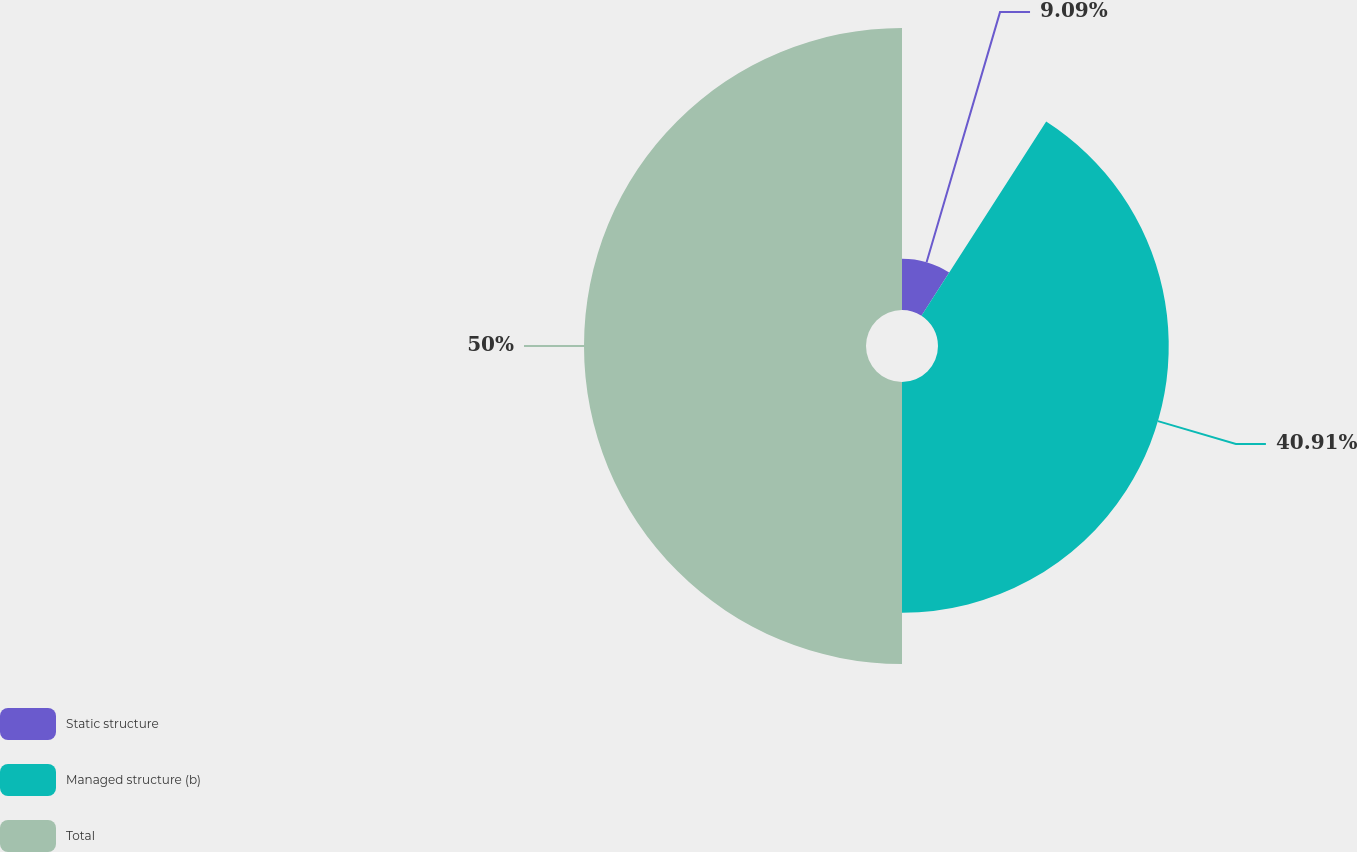<chart> <loc_0><loc_0><loc_500><loc_500><pie_chart><fcel>Static structure<fcel>Managed structure (b)<fcel>Total<nl><fcel>9.09%<fcel>40.91%<fcel>50.0%<nl></chart> 